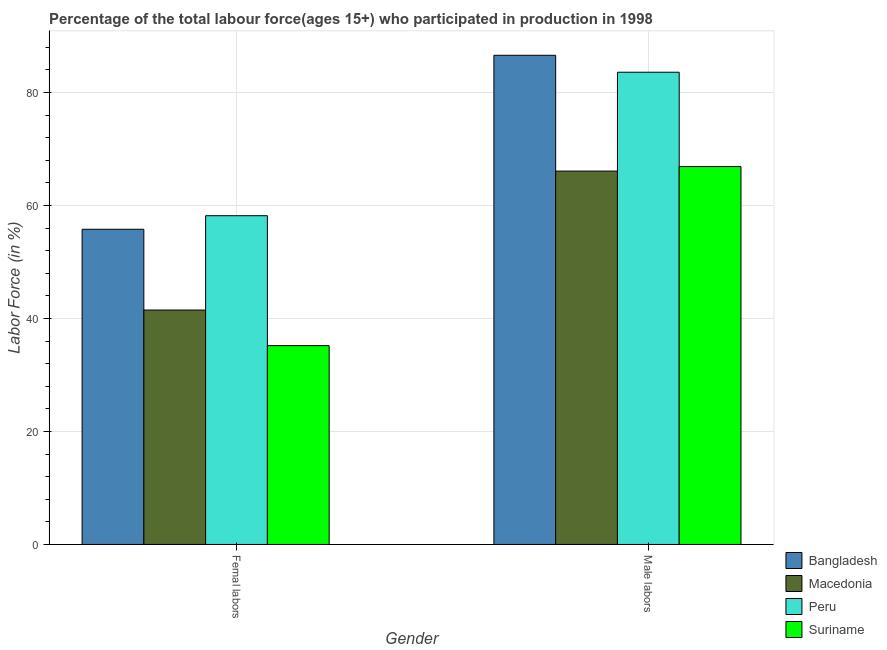How many groups of bars are there?
Provide a short and direct response. 2. Are the number of bars per tick equal to the number of legend labels?
Ensure brevity in your answer.  Yes. What is the label of the 2nd group of bars from the left?
Offer a terse response. Male labors. What is the percentage of male labour force in Bangladesh?
Make the answer very short. 86.6. Across all countries, what is the maximum percentage of female labor force?
Offer a very short reply. 58.2. Across all countries, what is the minimum percentage of female labor force?
Keep it short and to the point. 35.2. In which country was the percentage of female labor force maximum?
Provide a short and direct response. Peru. In which country was the percentage of female labor force minimum?
Provide a short and direct response. Suriname. What is the total percentage of male labour force in the graph?
Offer a very short reply. 303.2. What is the difference between the percentage of male labour force in Macedonia and that in Peru?
Your answer should be very brief. -17.5. What is the difference between the percentage of male labour force in Macedonia and the percentage of female labor force in Peru?
Your answer should be very brief. 7.9. What is the average percentage of male labour force per country?
Your response must be concise. 75.8. What is the difference between the percentage of female labor force and percentage of male labour force in Peru?
Ensure brevity in your answer.  -25.4. In how many countries, is the percentage of male labour force greater than 4 %?
Your answer should be very brief. 4. What is the ratio of the percentage of male labour force in Suriname to that in Peru?
Your response must be concise. 0.8. What does the 3rd bar from the left in Male labors represents?
Give a very brief answer. Peru. What does the 4th bar from the right in Male labors represents?
Offer a very short reply. Bangladesh. Are all the bars in the graph horizontal?
Offer a terse response. No. How many countries are there in the graph?
Your answer should be very brief. 4. What is the difference between two consecutive major ticks on the Y-axis?
Give a very brief answer. 20. Are the values on the major ticks of Y-axis written in scientific E-notation?
Make the answer very short. No. Does the graph contain any zero values?
Ensure brevity in your answer.  No. How are the legend labels stacked?
Your answer should be compact. Vertical. What is the title of the graph?
Ensure brevity in your answer.  Percentage of the total labour force(ages 15+) who participated in production in 1998. Does "Kenya" appear as one of the legend labels in the graph?
Your response must be concise. No. What is the label or title of the X-axis?
Provide a succinct answer. Gender. What is the Labor Force (in %) of Bangladesh in Femal labors?
Provide a short and direct response. 55.8. What is the Labor Force (in %) in Macedonia in Femal labors?
Keep it short and to the point. 41.5. What is the Labor Force (in %) of Peru in Femal labors?
Ensure brevity in your answer.  58.2. What is the Labor Force (in %) in Suriname in Femal labors?
Offer a terse response. 35.2. What is the Labor Force (in %) of Bangladesh in Male labors?
Offer a very short reply. 86.6. What is the Labor Force (in %) in Macedonia in Male labors?
Give a very brief answer. 66.1. What is the Labor Force (in %) in Peru in Male labors?
Provide a succinct answer. 83.6. What is the Labor Force (in %) in Suriname in Male labors?
Provide a short and direct response. 66.9. Across all Gender, what is the maximum Labor Force (in %) of Bangladesh?
Offer a terse response. 86.6. Across all Gender, what is the maximum Labor Force (in %) of Macedonia?
Make the answer very short. 66.1. Across all Gender, what is the maximum Labor Force (in %) of Peru?
Offer a very short reply. 83.6. Across all Gender, what is the maximum Labor Force (in %) in Suriname?
Your answer should be very brief. 66.9. Across all Gender, what is the minimum Labor Force (in %) of Bangladesh?
Provide a short and direct response. 55.8. Across all Gender, what is the minimum Labor Force (in %) of Macedonia?
Provide a short and direct response. 41.5. Across all Gender, what is the minimum Labor Force (in %) of Peru?
Offer a terse response. 58.2. Across all Gender, what is the minimum Labor Force (in %) in Suriname?
Your answer should be compact. 35.2. What is the total Labor Force (in %) in Bangladesh in the graph?
Offer a very short reply. 142.4. What is the total Labor Force (in %) of Macedonia in the graph?
Your response must be concise. 107.6. What is the total Labor Force (in %) of Peru in the graph?
Your answer should be very brief. 141.8. What is the total Labor Force (in %) of Suriname in the graph?
Your answer should be very brief. 102.1. What is the difference between the Labor Force (in %) of Bangladesh in Femal labors and that in Male labors?
Your response must be concise. -30.8. What is the difference between the Labor Force (in %) of Macedonia in Femal labors and that in Male labors?
Your answer should be very brief. -24.6. What is the difference between the Labor Force (in %) in Peru in Femal labors and that in Male labors?
Provide a succinct answer. -25.4. What is the difference between the Labor Force (in %) in Suriname in Femal labors and that in Male labors?
Ensure brevity in your answer.  -31.7. What is the difference between the Labor Force (in %) in Bangladesh in Femal labors and the Labor Force (in %) in Macedonia in Male labors?
Give a very brief answer. -10.3. What is the difference between the Labor Force (in %) in Bangladesh in Femal labors and the Labor Force (in %) in Peru in Male labors?
Make the answer very short. -27.8. What is the difference between the Labor Force (in %) of Macedonia in Femal labors and the Labor Force (in %) of Peru in Male labors?
Give a very brief answer. -42.1. What is the difference between the Labor Force (in %) in Macedonia in Femal labors and the Labor Force (in %) in Suriname in Male labors?
Offer a very short reply. -25.4. What is the average Labor Force (in %) of Bangladesh per Gender?
Your response must be concise. 71.2. What is the average Labor Force (in %) in Macedonia per Gender?
Give a very brief answer. 53.8. What is the average Labor Force (in %) of Peru per Gender?
Your answer should be very brief. 70.9. What is the average Labor Force (in %) in Suriname per Gender?
Give a very brief answer. 51.05. What is the difference between the Labor Force (in %) of Bangladesh and Labor Force (in %) of Suriname in Femal labors?
Offer a very short reply. 20.6. What is the difference between the Labor Force (in %) of Macedonia and Labor Force (in %) of Peru in Femal labors?
Provide a short and direct response. -16.7. What is the difference between the Labor Force (in %) of Bangladesh and Labor Force (in %) of Peru in Male labors?
Your answer should be compact. 3. What is the difference between the Labor Force (in %) in Bangladesh and Labor Force (in %) in Suriname in Male labors?
Your response must be concise. 19.7. What is the difference between the Labor Force (in %) in Macedonia and Labor Force (in %) in Peru in Male labors?
Provide a short and direct response. -17.5. What is the difference between the Labor Force (in %) of Macedonia and Labor Force (in %) of Suriname in Male labors?
Provide a succinct answer. -0.8. What is the difference between the Labor Force (in %) of Peru and Labor Force (in %) of Suriname in Male labors?
Make the answer very short. 16.7. What is the ratio of the Labor Force (in %) in Bangladesh in Femal labors to that in Male labors?
Make the answer very short. 0.64. What is the ratio of the Labor Force (in %) in Macedonia in Femal labors to that in Male labors?
Your answer should be compact. 0.63. What is the ratio of the Labor Force (in %) in Peru in Femal labors to that in Male labors?
Provide a succinct answer. 0.7. What is the ratio of the Labor Force (in %) in Suriname in Femal labors to that in Male labors?
Your answer should be compact. 0.53. What is the difference between the highest and the second highest Labor Force (in %) of Bangladesh?
Keep it short and to the point. 30.8. What is the difference between the highest and the second highest Labor Force (in %) in Macedonia?
Give a very brief answer. 24.6. What is the difference between the highest and the second highest Labor Force (in %) in Peru?
Your answer should be very brief. 25.4. What is the difference between the highest and the second highest Labor Force (in %) in Suriname?
Offer a very short reply. 31.7. What is the difference between the highest and the lowest Labor Force (in %) in Bangladesh?
Offer a very short reply. 30.8. What is the difference between the highest and the lowest Labor Force (in %) of Macedonia?
Your answer should be compact. 24.6. What is the difference between the highest and the lowest Labor Force (in %) in Peru?
Your answer should be very brief. 25.4. What is the difference between the highest and the lowest Labor Force (in %) of Suriname?
Your answer should be very brief. 31.7. 